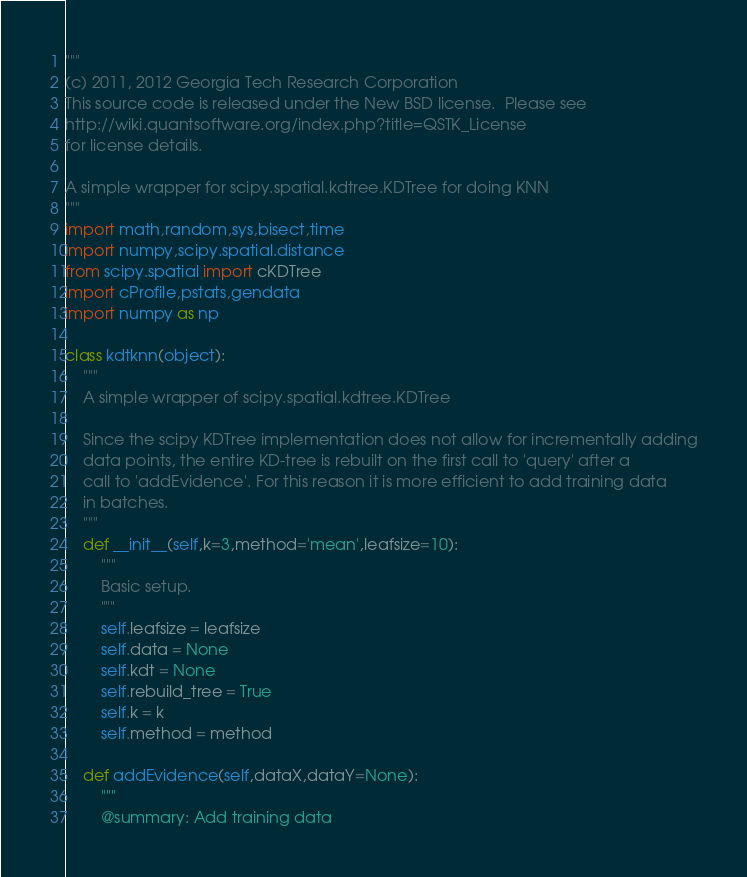Convert code to text. <code><loc_0><loc_0><loc_500><loc_500><_Python_>"""
(c) 2011, 2012 Georgia Tech Research Corporation
This source code is released under the New BSD license.  Please see
http://wiki.quantsoftware.org/index.php?title=QSTK_License
for license details.

A simple wrapper for scipy.spatial.kdtree.KDTree for doing KNN
"""
import math,random,sys,bisect,time
import numpy,scipy.spatial.distance
from scipy.spatial import cKDTree
import cProfile,pstats,gendata
import numpy as np

class kdtknn(object):
    """
    A simple wrapper of scipy.spatial.kdtree.KDTree
    
    Since the scipy KDTree implementation does not allow for incrementally adding
    data points, the entire KD-tree is rebuilt on the first call to 'query' after a
    call to 'addEvidence'. For this reason it is more efficient to add training data
    in batches.
    """
    def __init__(self,k=3,method='mean',leafsize=10):
        """
        Basic setup.
        """
        self.leafsize = leafsize
        self.data = None
        self.kdt = None
        self.rebuild_tree = True
        self.k = k
        self.method = method

    def addEvidence(self,dataX,dataY=None):
        """
        @summary: Add training data</code> 